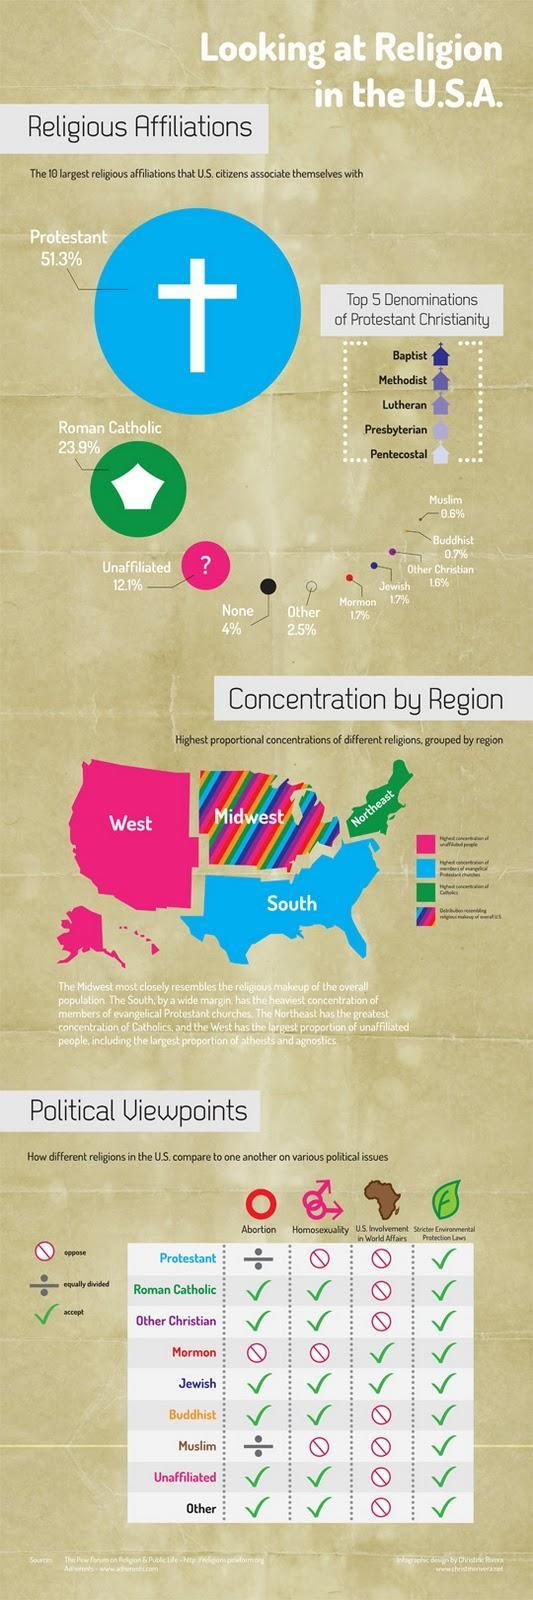Which region does the multicolored portion of the map represent?
Answer the question with a short phrase. Midwest What is the percentage contributed by Muslims, Buddhist and Other Christians? 2.9% What is written on the green portion of the map? Northeast What is color of the portion marked South, blue, green, pink or multicolored? blue What is the total percentage of religious affiliations contributed by Unaffiliated, None and Others? 18.6% Which two religious affiliation contributes 1.7% percentage? Mormon and Jewish What is written on the pink portion of the map? West Which has a higher percentage value of religious affiliations in the US, Unaffiliated or Roman Catholic? Roman Catholic 